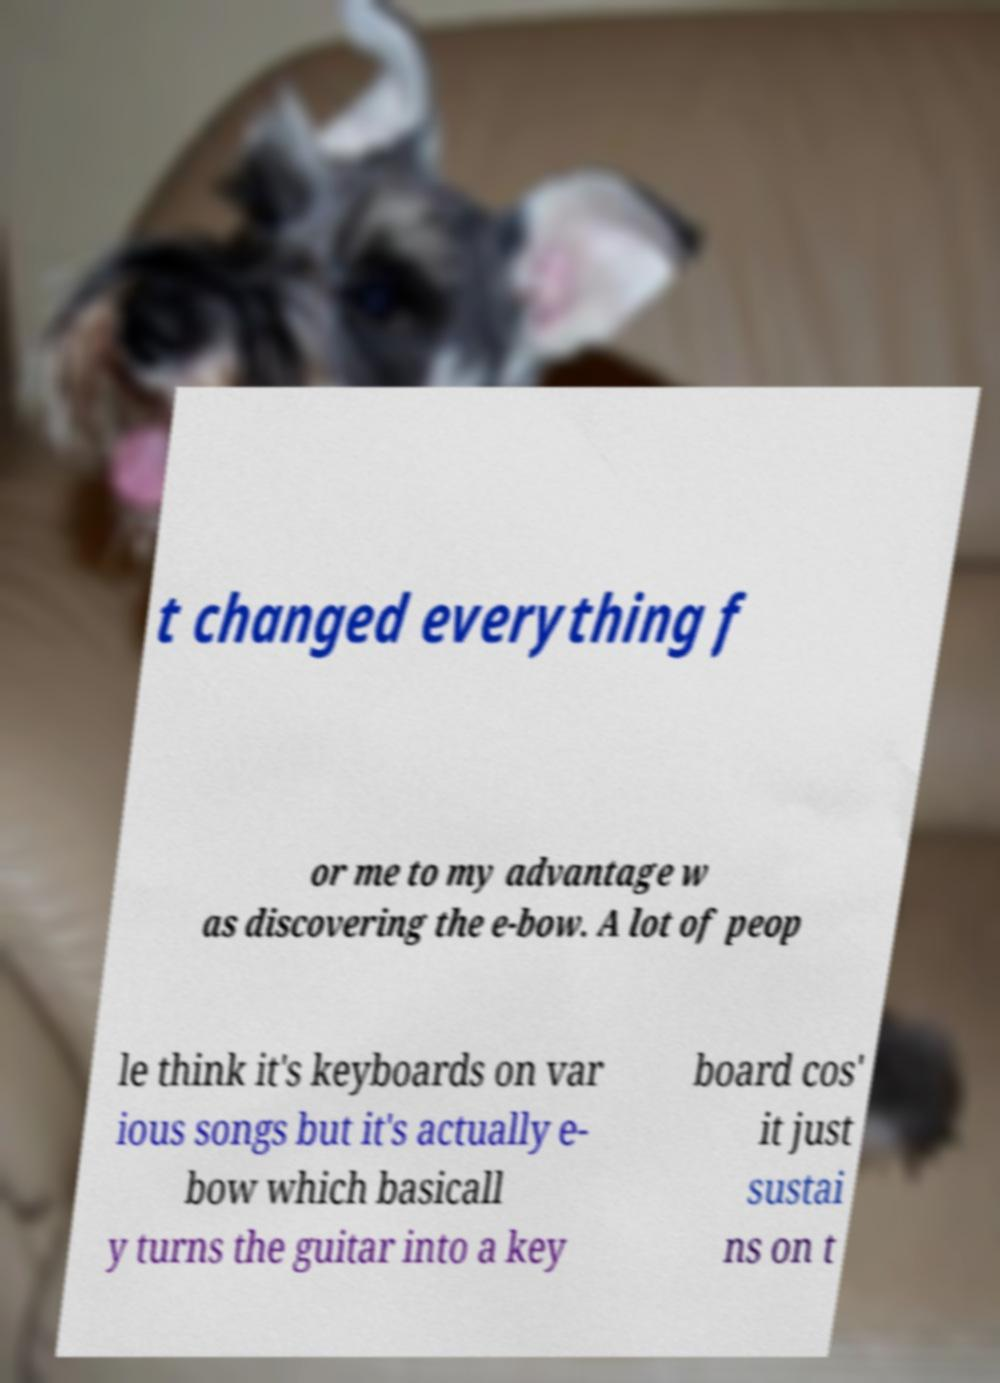There's text embedded in this image that I need extracted. Can you transcribe it verbatim? t changed everything f or me to my advantage w as discovering the e-bow. A lot of peop le think it's keyboards on var ious songs but it's actually e- bow which basicall y turns the guitar into a key board cos' it just sustai ns on t 